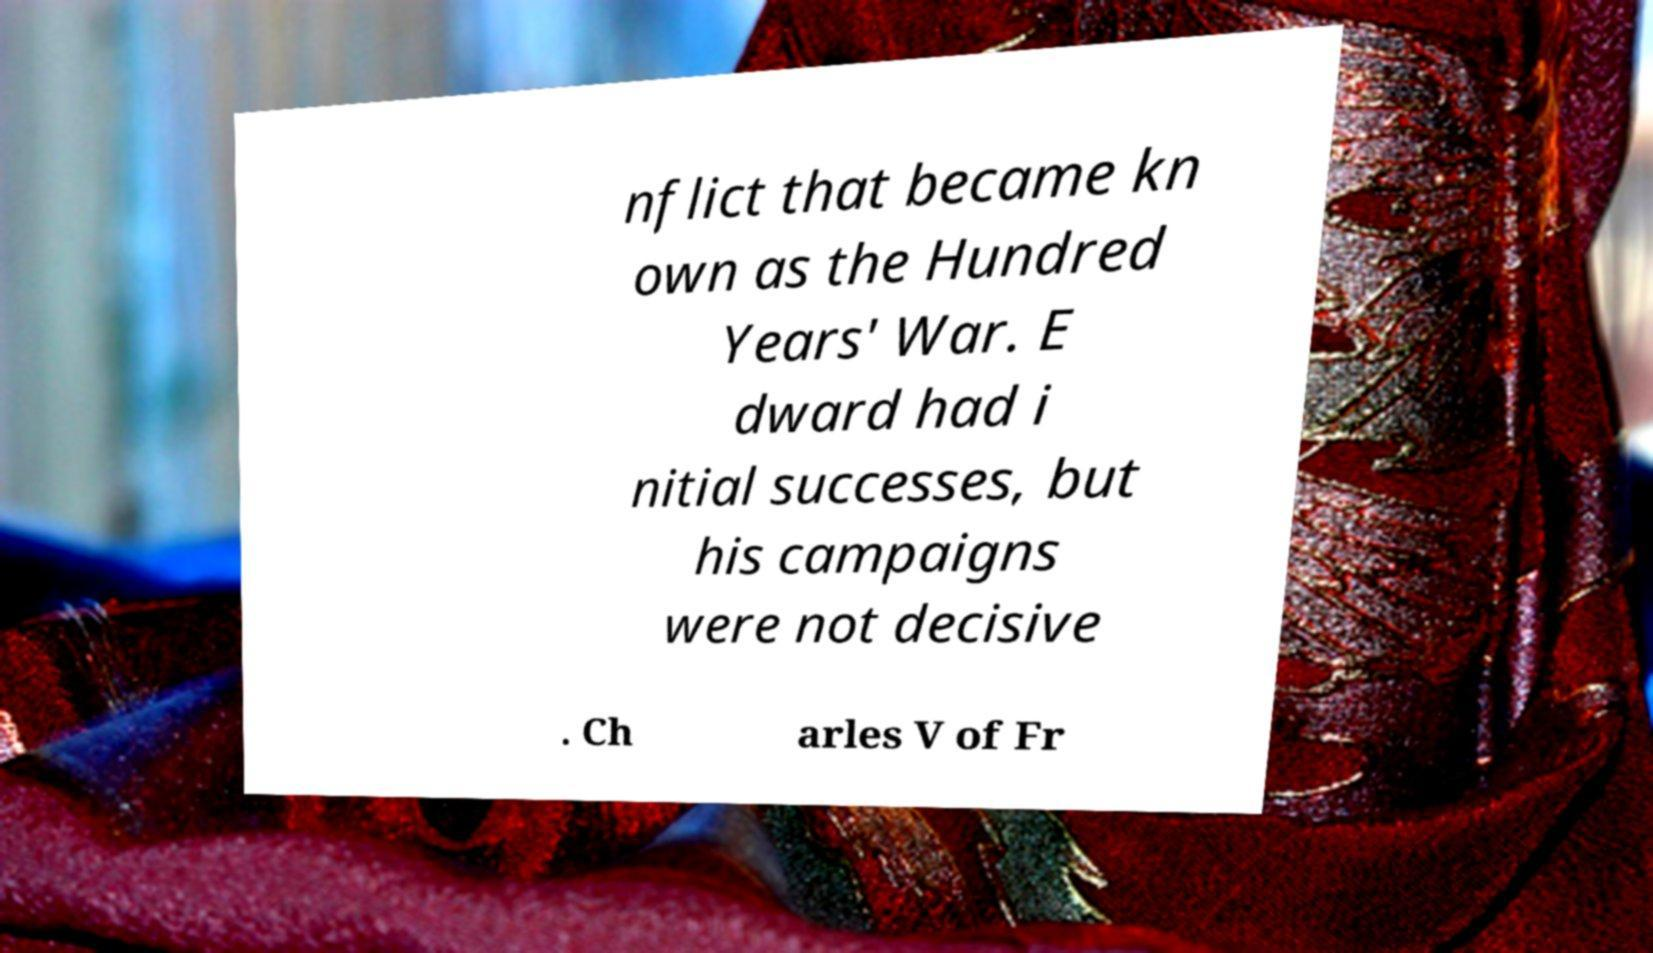Can you read and provide the text displayed in the image?This photo seems to have some interesting text. Can you extract and type it out for me? nflict that became kn own as the Hundred Years' War. E dward had i nitial successes, but his campaigns were not decisive . Ch arles V of Fr 